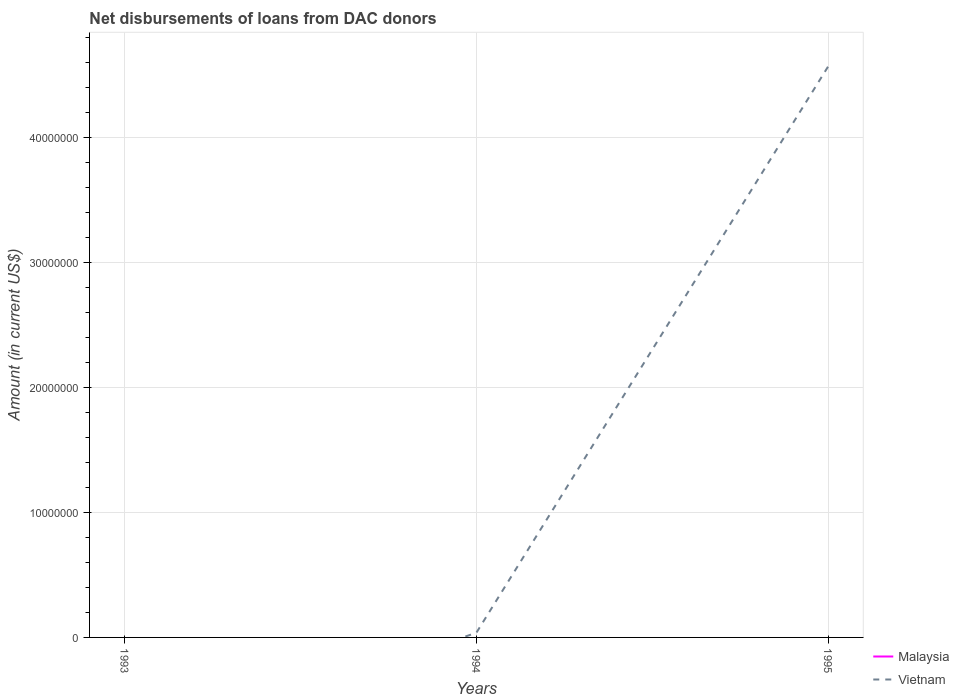Across all years, what is the maximum amount of loans disbursed in Vietnam?
Give a very brief answer. 0. What is the total amount of loans disbursed in Vietnam in the graph?
Make the answer very short. -4.53e+07. What is the difference between the highest and the second highest amount of loans disbursed in Vietnam?
Provide a short and direct response. 4.57e+07. What is the difference between the highest and the lowest amount of loans disbursed in Malaysia?
Ensure brevity in your answer.  0. Is the amount of loans disbursed in Malaysia strictly greater than the amount of loans disbursed in Vietnam over the years?
Ensure brevity in your answer.  No. How many lines are there?
Provide a short and direct response. 1. How many years are there in the graph?
Keep it short and to the point. 3. What is the difference between two consecutive major ticks on the Y-axis?
Provide a succinct answer. 1.00e+07. Does the graph contain grids?
Your response must be concise. Yes. Where does the legend appear in the graph?
Make the answer very short. Bottom right. How many legend labels are there?
Your answer should be very brief. 2. How are the legend labels stacked?
Your answer should be very brief. Vertical. What is the title of the graph?
Offer a terse response. Net disbursements of loans from DAC donors. Does "Iran" appear as one of the legend labels in the graph?
Give a very brief answer. No. What is the label or title of the Y-axis?
Ensure brevity in your answer.  Amount (in current US$). What is the Amount (in current US$) of Malaysia in 1993?
Offer a very short reply. 0. What is the Amount (in current US$) in Vietnam in 1994?
Your answer should be very brief. 3.73e+05. What is the Amount (in current US$) in Malaysia in 1995?
Keep it short and to the point. 0. What is the Amount (in current US$) in Vietnam in 1995?
Offer a terse response. 4.57e+07. Across all years, what is the maximum Amount (in current US$) of Vietnam?
Give a very brief answer. 4.57e+07. Across all years, what is the minimum Amount (in current US$) in Vietnam?
Provide a succinct answer. 0. What is the total Amount (in current US$) of Vietnam in the graph?
Your answer should be very brief. 4.61e+07. What is the difference between the Amount (in current US$) in Vietnam in 1994 and that in 1995?
Keep it short and to the point. -4.53e+07. What is the average Amount (in current US$) in Malaysia per year?
Ensure brevity in your answer.  0. What is the average Amount (in current US$) of Vietnam per year?
Ensure brevity in your answer.  1.54e+07. What is the ratio of the Amount (in current US$) of Vietnam in 1994 to that in 1995?
Ensure brevity in your answer.  0.01. What is the difference between the highest and the lowest Amount (in current US$) in Vietnam?
Provide a succinct answer. 4.57e+07. 